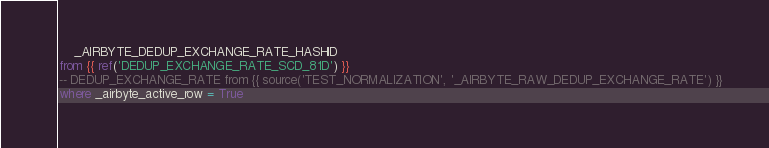Convert code to text. <code><loc_0><loc_0><loc_500><loc_500><_SQL_>    _AIRBYTE_DEDUP_EXCHANGE_RATE_HASHID
from {{ ref('DEDUP_EXCHANGE_RATE_SCD_81D') }}
-- DEDUP_EXCHANGE_RATE from {{ source('TEST_NORMALIZATION', '_AIRBYTE_RAW_DEDUP_EXCHANGE_RATE') }}
where _airbyte_active_row = True

</code> 